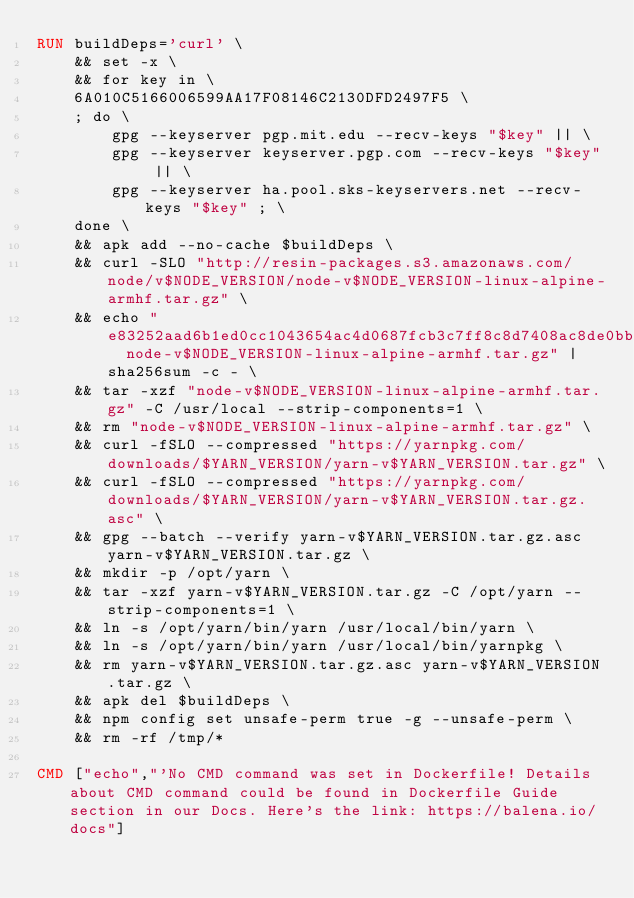<code> <loc_0><loc_0><loc_500><loc_500><_Dockerfile_>RUN buildDeps='curl' \
	&& set -x \
	&& for key in \
	6A010C5166006599AA17F08146C2130DFD2497F5 \
	; do \
		gpg --keyserver pgp.mit.edu --recv-keys "$key" || \
		gpg --keyserver keyserver.pgp.com --recv-keys "$key" || \
		gpg --keyserver ha.pool.sks-keyservers.net --recv-keys "$key" ; \
	done \
	&& apk add --no-cache $buildDeps \
	&& curl -SLO "http://resin-packages.s3.amazonaws.com/node/v$NODE_VERSION/node-v$NODE_VERSION-linux-alpine-armhf.tar.gz" \
	&& echo "e83252aad6b1ed0cc1043654ac4d0687fcb3c7ff8c8d7408ac8de0bb810fdeaf  node-v$NODE_VERSION-linux-alpine-armhf.tar.gz" | sha256sum -c - \
	&& tar -xzf "node-v$NODE_VERSION-linux-alpine-armhf.tar.gz" -C /usr/local --strip-components=1 \
	&& rm "node-v$NODE_VERSION-linux-alpine-armhf.tar.gz" \
	&& curl -fSLO --compressed "https://yarnpkg.com/downloads/$YARN_VERSION/yarn-v$YARN_VERSION.tar.gz" \
	&& curl -fSLO --compressed "https://yarnpkg.com/downloads/$YARN_VERSION/yarn-v$YARN_VERSION.tar.gz.asc" \
	&& gpg --batch --verify yarn-v$YARN_VERSION.tar.gz.asc yarn-v$YARN_VERSION.tar.gz \
	&& mkdir -p /opt/yarn \
	&& tar -xzf yarn-v$YARN_VERSION.tar.gz -C /opt/yarn --strip-components=1 \
	&& ln -s /opt/yarn/bin/yarn /usr/local/bin/yarn \
	&& ln -s /opt/yarn/bin/yarn /usr/local/bin/yarnpkg \
	&& rm yarn-v$YARN_VERSION.tar.gz.asc yarn-v$YARN_VERSION.tar.gz \
	&& apk del $buildDeps \
	&& npm config set unsafe-perm true -g --unsafe-perm \
	&& rm -rf /tmp/*

CMD ["echo","'No CMD command was set in Dockerfile! Details about CMD command could be found in Dockerfile Guide section in our Docs. Here's the link: https://balena.io/docs"]</code> 